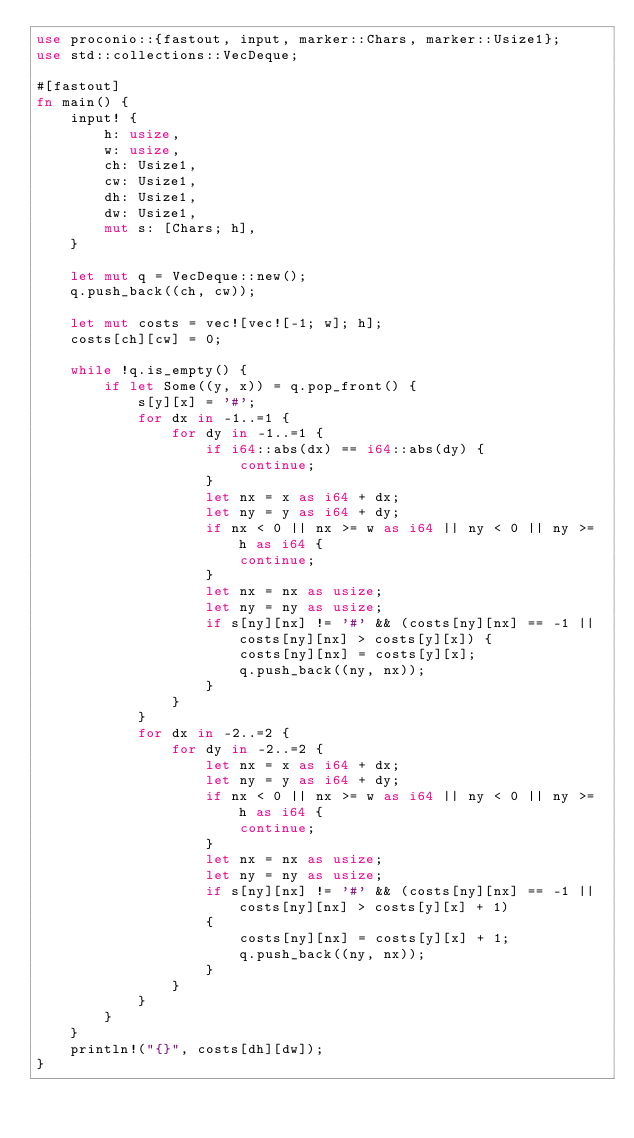<code> <loc_0><loc_0><loc_500><loc_500><_Rust_>use proconio::{fastout, input, marker::Chars, marker::Usize1};
use std::collections::VecDeque;

#[fastout]
fn main() {
    input! {
        h: usize,
        w: usize,
        ch: Usize1,
        cw: Usize1,
        dh: Usize1,
        dw: Usize1,
        mut s: [Chars; h],
    }

    let mut q = VecDeque::new();
    q.push_back((ch, cw));

    let mut costs = vec![vec![-1; w]; h];
    costs[ch][cw] = 0;

    while !q.is_empty() {
        if let Some((y, x)) = q.pop_front() {
            s[y][x] = '#';
            for dx in -1..=1 {
                for dy in -1..=1 {
                    if i64::abs(dx) == i64::abs(dy) {
                        continue;
                    }
                    let nx = x as i64 + dx;
                    let ny = y as i64 + dy;
                    if nx < 0 || nx >= w as i64 || ny < 0 || ny >= h as i64 {
                        continue;
                    }
                    let nx = nx as usize;
                    let ny = ny as usize;
                    if s[ny][nx] != '#' && (costs[ny][nx] == -1 || costs[ny][nx] > costs[y][x]) {
                        costs[ny][nx] = costs[y][x];
                        q.push_back((ny, nx));
                    }
                }
            }
            for dx in -2..=2 {
                for dy in -2..=2 {
                    let nx = x as i64 + dx;
                    let ny = y as i64 + dy;
                    if nx < 0 || nx >= w as i64 || ny < 0 || ny >= h as i64 {
                        continue;
                    }
                    let nx = nx as usize;
                    let ny = ny as usize;
                    if s[ny][nx] != '#' && (costs[ny][nx] == -1 || costs[ny][nx] > costs[y][x] + 1)
                    {
                        costs[ny][nx] = costs[y][x] + 1;
                        q.push_back((ny, nx));
                    }
                }
            }
        }
    }
    println!("{}", costs[dh][dw]);
}
</code> 